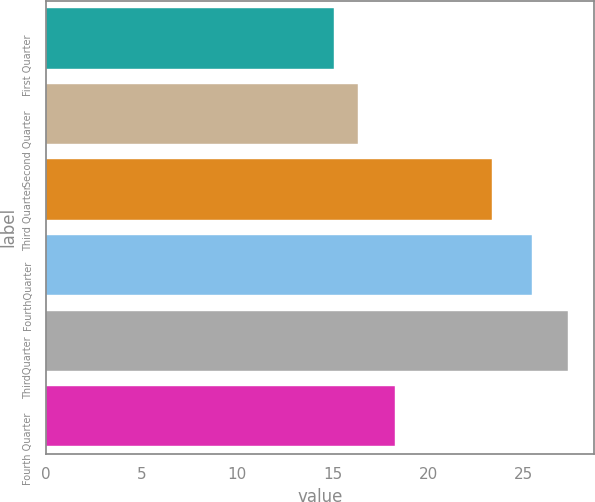<chart> <loc_0><loc_0><loc_500><loc_500><bar_chart><fcel>First Quarter<fcel>Second Quarter<fcel>Third Quarter<fcel>FourthQuarter<fcel>ThirdQuarter<fcel>Fourth Quarter<nl><fcel>15.05<fcel>16.31<fcel>23.32<fcel>25.44<fcel>27.29<fcel>18.25<nl></chart> 